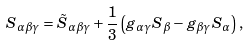Convert formula to latex. <formula><loc_0><loc_0><loc_500><loc_500>S _ { \alpha \beta \gamma } = \tilde { S } _ { \alpha \beta \gamma } + \frac { 1 } { 3 } \left ( g _ { \alpha \gamma } S _ { \beta } - g _ { \beta \gamma } S _ { \alpha } \right ) ,</formula> 